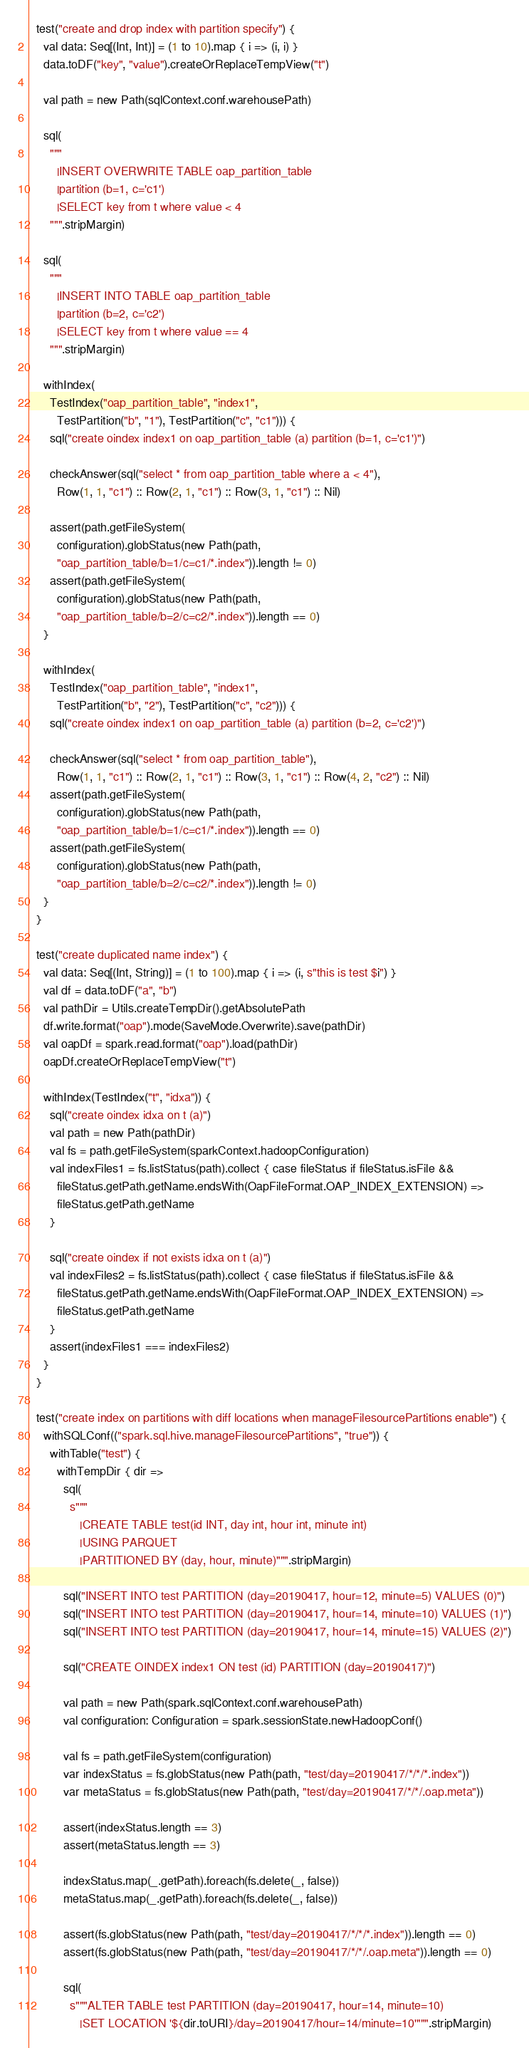Convert code to text. <code><loc_0><loc_0><loc_500><loc_500><_Scala_>
  test("create and drop index with partition specify") {
    val data: Seq[(Int, Int)] = (1 to 10).map { i => (i, i) }
    data.toDF("key", "value").createOrReplaceTempView("t")

    val path = new Path(sqlContext.conf.warehousePath)

    sql(
      """
        |INSERT OVERWRITE TABLE oap_partition_table
        |partition (b=1, c='c1')
        |SELECT key from t where value < 4
      """.stripMargin)

    sql(
      """
        |INSERT INTO TABLE oap_partition_table
        |partition (b=2, c='c2')
        |SELECT key from t where value == 4
      """.stripMargin)

    withIndex(
      TestIndex("oap_partition_table", "index1",
        TestPartition("b", "1"), TestPartition("c", "c1"))) {
      sql("create oindex index1 on oap_partition_table (a) partition (b=1, c='c1')")

      checkAnswer(sql("select * from oap_partition_table where a < 4"),
        Row(1, 1, "c1") :: Row(2, 1, "c1") :: Row(3, 1, "c1") :: Nil)

      assert(path.getFileSystem(
        configuration).globStatus(new Path(path,
        "oap_partition_table/b=1/c=c1/*.index")).length != 0)
      assert(path.getFileSystem(
        configuration).globStatus(new Path(path,
        "oap_partition_table/b=2/c=c2/*.index")).length == 0)
    }

    withIndex(
      TestIndex("oap_partition_table", "index1",
        TestPartition("b", "2"), TestPartition("c", "c2"))) {
      sql("create oindex index1 on oap_partition_table (a) partition (b=2, c='c2')")

      checkAnswer(sql("select * from oap_partition_table"),
        Row(1, 1, "c1") :: Row(2, 1, "c1") :: Row(3, 1, "c1") :: Row(4, 2, "c2") :: Nil)
      assert(path.getFileSystem(
        configuration).globStatus(new Path(path,
        "oap_partition_table/b=1/c=c1/*.index")).length == 0)
      assert(path.getFileSystem(
        configuration).globStatus(new Path(path,
        "oap_partition_table/b=2/c=c2/*.index")).length != 0)
    }
  }

  test("create duplicated name index") {
    val data: Seq[(Int, String)] = (1 to 100).map { i => (i, s"this is test $i") }
    val df = data.toDF("a", "b")
    val pathDir = Utils.createTempDir().getAbsolutePath
    df.write.format("oap").mode(SaveMode.Overwrite).save(pathDir)
    val oapDf = spark.read.format("oap").load(pathDir)
    oapDf.createOrReplaceTempView("t")

    withIndex(TestIndex("t", "idxa")) {
      sql("create oindex idxa on t (a)")
      val path = new Path(pathDir)
      val fs = path.getFileSystem(sparkContext.hadoopConfiguration)
      val indexFiles1 = fs.listStatus(path).collect { case fileStatus if fileStatus.isFile &&
        fileStatus.getPath.getName.endsWith(OapFileFormat.OAP_INDEX_EXTENSION) =>
        fileStatus.getPath.getName
      }

      sql("create oindex if not exists idxa on t (a)")
      val indexFiles2 = fs.listStatus(path).collect { case fileStatus if fileStatus.isFile &&
        fileStatus.getPath.getName.endsWith(OapFileFormat.OAP_INDEX_EXTENSION) =>
        fileStatus.getPath.getName
      }
      assert(indexFiles1 === indexFiles2)
    }
  }

  test("create index on partitions with diff locations when manageFilesourcePartitions enable") {
    withSQLConf(("spark.sql.hive.manageFilesourcePartitions", "true")) {
      withTable("test") {
        withTempDir { dir =>
          sql(
            s"""
               |CREATE TABLE test(id INT, day int, hour int, minute int)
               |USING PARQUET
               |PARTITIONED BY (day, hour, minute)""".stripMargin)

          sql("INSERT INTO test PARTITION (day=20190417, hour=12, minute=5) VALUES (0)")
          sql("INSERT INTO test PARTITION (day=20190417, hour=14, minute=10) VALUES (1)")
          sql("INSERT INTO test PARTITION (day=20190417, hour=14, minute=15) VALUES (2)")

          sql("CREATE OINDEX index1 ON test (id) PARTITION (day=20190417)")

          val path = new Path(spark.sqlContext.conf.warehousePath)
          val configuration: Configuration = spark.sessionState.newHadoopConf()

          val fs = path.getFileSystem(configuration)
          var indexStatus = fs.globStatus(new Path(path, "test/day=20190417/*/*/*.index"))
          var metaStatus = fs.globStatus(new Path(path, "test/day=20190417/*/*/.oap.meta"))

          assert(indexStatus.length == 3)
          assert(metaStatus.length == 3)

          indexStatus.map(_.getPath).foreach(fs.delete(_, false))
          metaStatus.map(_.getPath).foreach(fs.delete(_, false))

          assert(fs.globStatus(new Path(path, "test/day=20190417/*/*/*.index")).length == 0)
          assert(fs.globStatus(new Path(path, "test/day=20190417/*/*/.oap.meta")).length == 0)

          sql(
            s"""ALTER TABLE test PARTITION (day=20190417, hour=14, minute=10)
               |SET LOCATION '${dir.toURI}/day=20190417/hour=14/minute=10'""".stripMargin)
</code> 